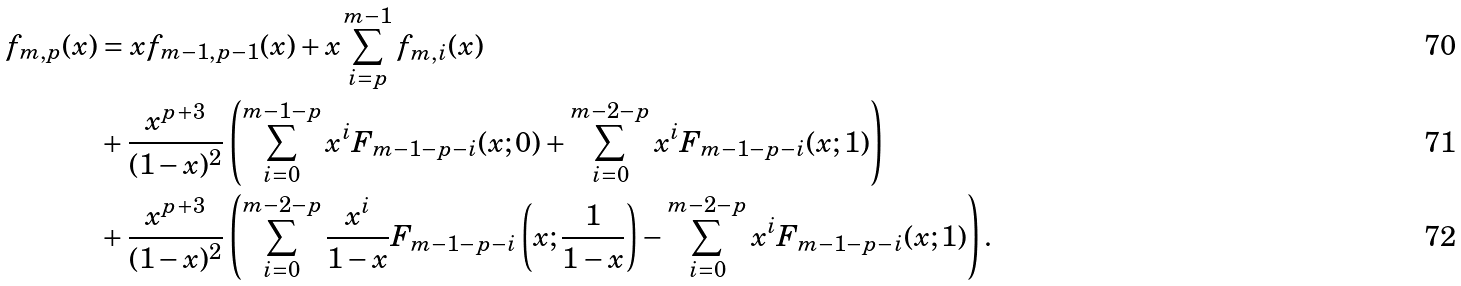Convert formula to latex. <formula><loc_0><loc_0><loc_500><loc_500>f _ { m , p } ( x ) & = x f _ { m - 1 , p - 1 } ( x ) + x \sum _ { i = p } ^ { m - 1 } f _ { m , i } ( x ) \\ & + \frac { x ^ { p + 3 } } { ( 1 - x ) ^ { 2 } } \left ( \sum _ { i = 0 } ^ { m - 1 - p } x ^ { i } F _ { m - 1 - p - i } ( x ; 0 ) + \sum _ { i = 0 } ^ { m - 2 - p } x ^ { i } F _ { m - 1 - p - i } ( x ; 1 ) \right ) \\ & + \frac { x ^ { p + 3 } } { ( 1 - x ) ^ { 2 } } \left ( \sum _ { i = 0 } ^ { m - 2 - p } \frac { x ^ { i } } { 1 - x } F _ { m - 1 - p - i } \left ( x ; \frac { 1 } { 1 - x } \right ) - \sum _ { i = 0 } ^ { m - 2 - p } x ^ { i } F _ { m - 1 - p - i } ( x ; 1 ) \right ) .</formula> 